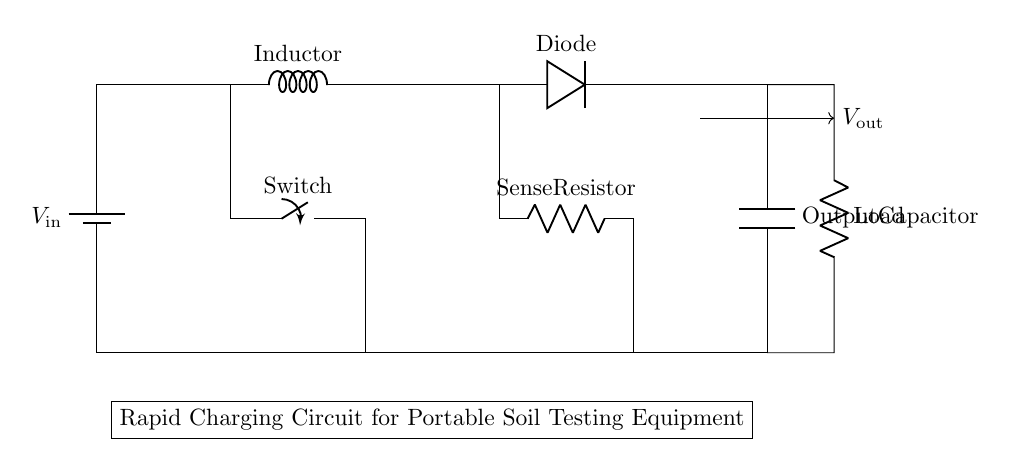What is the type of the first component in the circuit? The first component is a battery, which is indicated as a voltage source (labeled as V_in) providing power to the circuit.
Answer: Battery What is the function of the Diode in the circuit? The Diode allows current to flow in one direction only, preventing backflow and ensuring that the output from the capacitor only goes forward to power the load.
Answer: Prevent backflow What is the value of the load in this circuit? The value of the load resistor is not specifically indicated in the diagram, but it is labeled generically as a Load, suggesting it is a defined resistance necessary for the charging process.
Answer: Load What would happen if the switch is closed? Closing the switch would complete the circuit allowing current to flow from the battery through the inductor to charge the capacitor, enabling rapid charging of the soil testing equipment.
Answer: Complete the circuit What role does the Sense Resistor play in this circuit? The Sense Resistor measures current flowing through the circuit, helping to monitor and control charging levels to prevent overcharging and ensure the safety of the portable soil testing equipment.
Answer: Measure current How does the Output Capacitor affect the circuit's performance? The Output Capacitor stores energy and smoothens the voltage output to the load, which is critical for maintaining stable performance of the soil testing equipment during operation and charging.
Answer: Smoothens output What kind of circuit is represented in the diagram? The circuit is a rapid charging circuit designed specifically for portable soil testing equipment, focusing on efficient energy transfer and storage for quick recharging of instruments.
Answer: Rapid charging circuit 